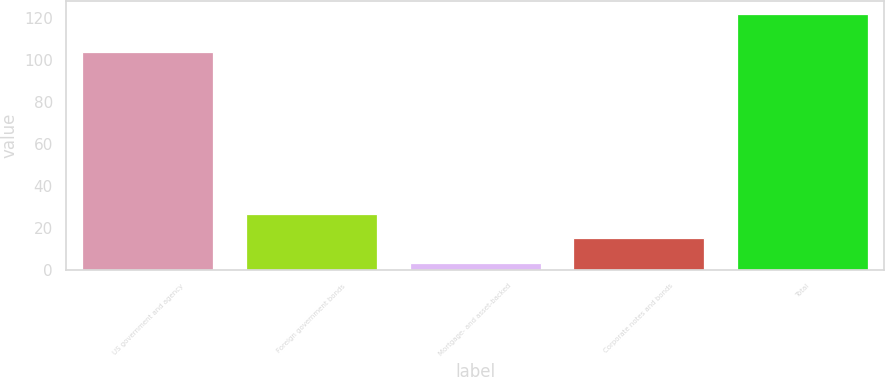<chart> <loc_0><loc_0><loc_500><loc_500><bar_chart><fcel>US government and agency<fcel>Foreign government bonds<fcel>Mortgage- and asset-backed<fcel>Corporate notes and bonds<fcel>Total<nl><fcel>104<fcel>26.8<fcel>3<fcel>14.9<fcel>122<nl></chart> 